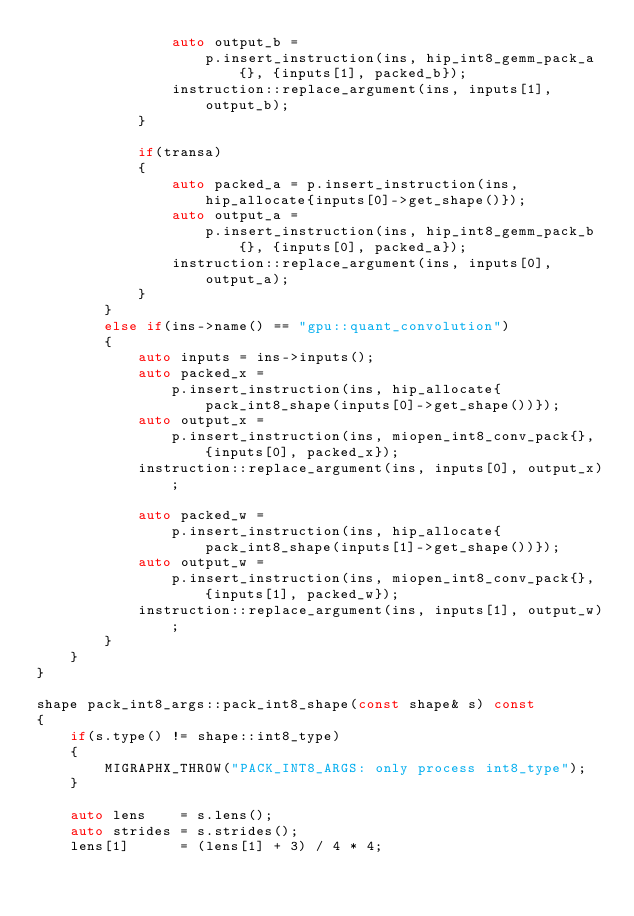<code> <loc_0><loc_0><loc_500><loc_500><_C++_>                auto output_b =
                    p.insert_instruction(ins, hip_int8_gemm_pack_a{}, {inputs[1], packed_b});
                instruction::replace_argument(ins, inputs[1], output_b);
            }

            if(transa)
            {
                auto packed_a = p.insert_instruction(ins, hip_allocate{inputs[0]->get_shape()});
                auto output_a =
                    p.insert_instruction(ins, hip_int8_gemm_pack_b{}, {inputs[0], packed_a});
                instruction::replace_argument(ins, inputs[0], output_a);
            }
        }
        else if(ins->name() == "gpu::quant_convolution")
        {
            auto inputs = ins->inputs();
            auto packed_x =
                p.insert_instruction(ins, hip_allocate{pack_int8_shape(inputs[0]->get_shape())});
            auto output_x =
                p.insert_instruction(ins, miopen_int8_conv_pack{}, {inputs[0], packed_x});
            instruction::replace_argument(ins, inputs[0], output_x);

            auto packed_w =
                p.insert_instruction(ins, hip_allocate{pack_int8_shape(inputs[1]->get_shape())});
            auto output_w =
                p.insert_instruction(ins, miopen_int8_conv_pack{}, {inputs[1], packed_w});
            instruction::replace_argument(ins, inputs[1], output_w);
        }
    }
}

shape pack_int8_args::pack_int8_shape(const shape& s) const
{
    if(s.type() != shape::int8_type)
    {
        MIGRAPHX_THROW("PACK_INT8_ARGS: only process int8_type");
    }

    auto lens    = s.lens();
    auto strides = s.strides();
    lens[1]      = (lens[1] + 3) / 4 * 4;</code> 